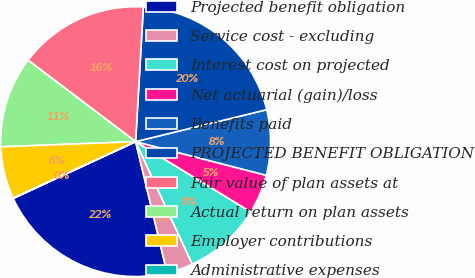<chart> <loc_0><loc_0><loc_500><loc_500><pie_chart><fcel>Projected benefit obligation<fcel>Service cost - excluding<fcel>Interest cost on projected<fcel>Net actuarial (gain)/loss<fcel>Benefits paid<fcel>PROJECTED BENEFIT OBLIGATION<fcel>Fair value of plan assets at<fcel>Actual return on plan assets<fcel>Employer contributions<fcel>Administrative expenses<nl><fcel>21.83%<fcel>3.15%<fcel>9.38%<fcel>4.71%<fcel>7.82%<fcel>20.28%<fcel>15.6%<fcel>10.93%<fcel>6.26%<fcel>0.04%<nl></chart> 